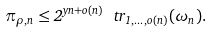Convert formula to latex. <formula><loc_0><loc_0><loc_500><loc_500>\pi _ { \rho , n } \leq 2 ^ { y n + o ( n ) } \ t r _ { 1 , \dots , o ( n ) } ( \omega _ { n } ) .</formula> 